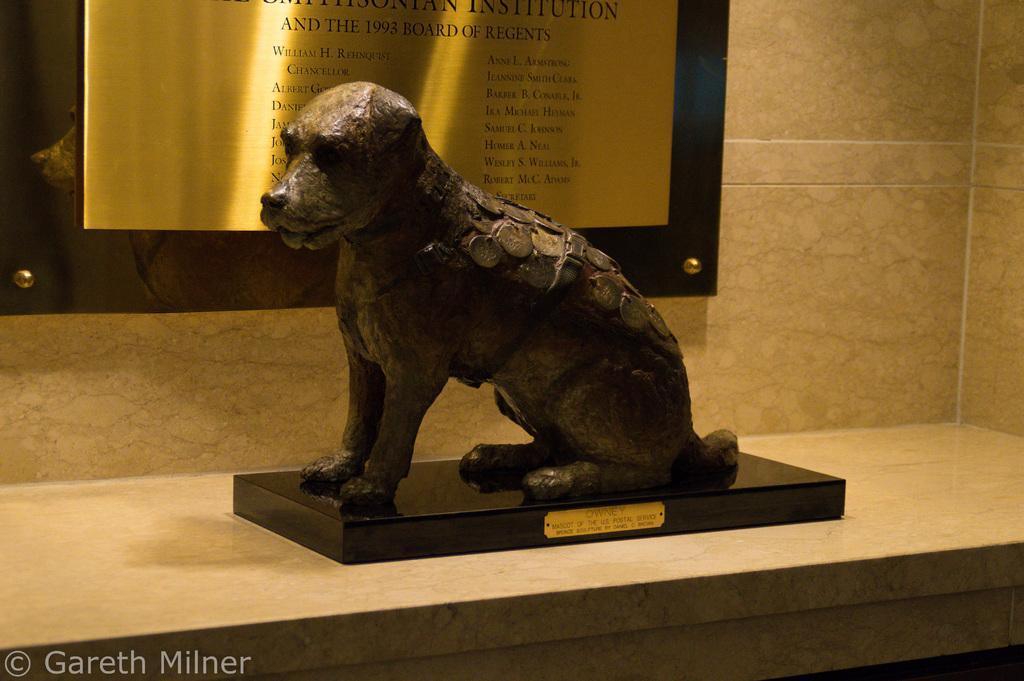Please provide a concise description of this image. In this image there is a animal sculpture on the table, beside that there is a bronze board on the wall with some note. 